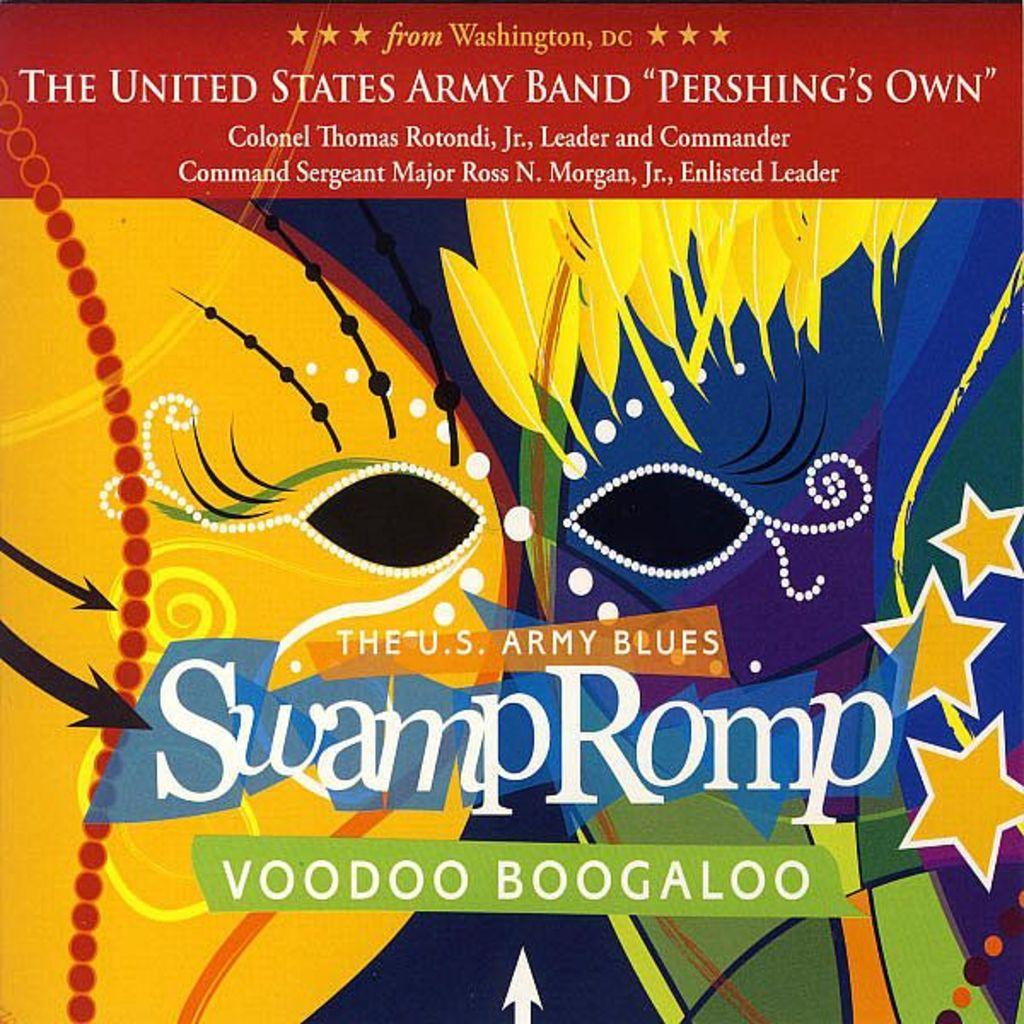<image>
Summarize the visual content of the image. The United States Army Band cover called SwampRomp. 